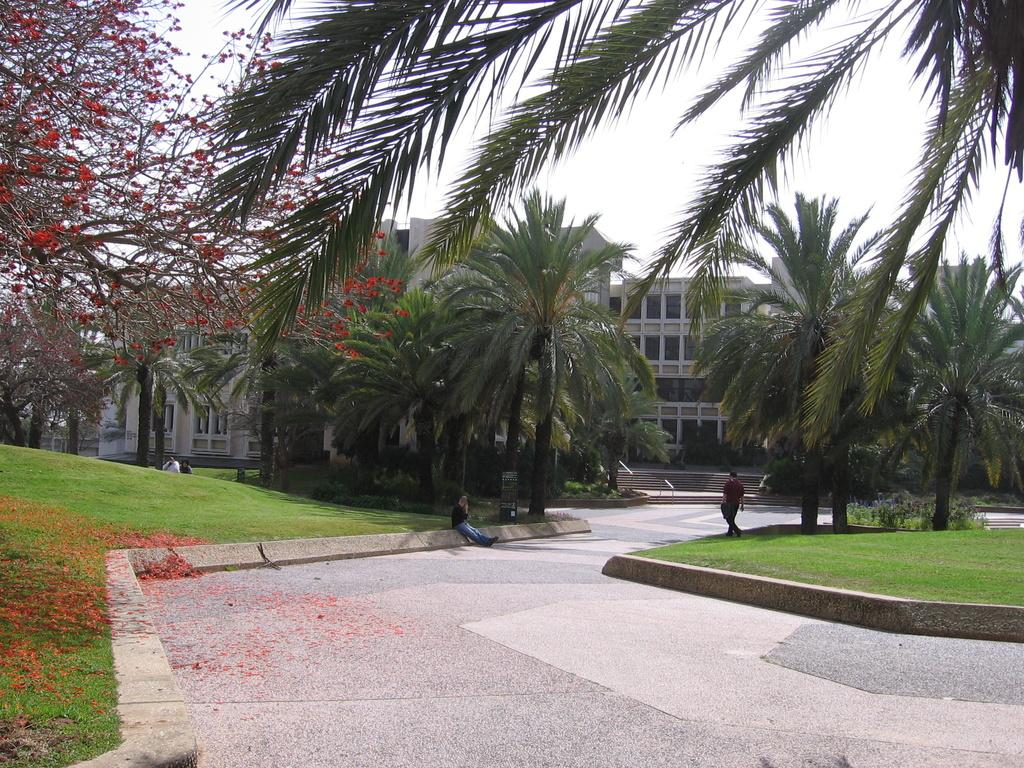What type of path is visible in the image? There is a walkway in the image. How many people can be seen in the image? There are two persons in the image. What type of vegetation is present in the image? There are trees in the image. What type of structures can be seen in the image? There are buildings in the image. What is visible in the background of the image? The sky is visible in the image. What type of print can be seen on the buildings in the image? There is no specific print mentioned on the buildings in the image; only the presence of buildings is noted. What type of punishment is being administered to the trees in the image? There is no punishment being administered to the trees in the image; they are simply present as part of the natural environment. 